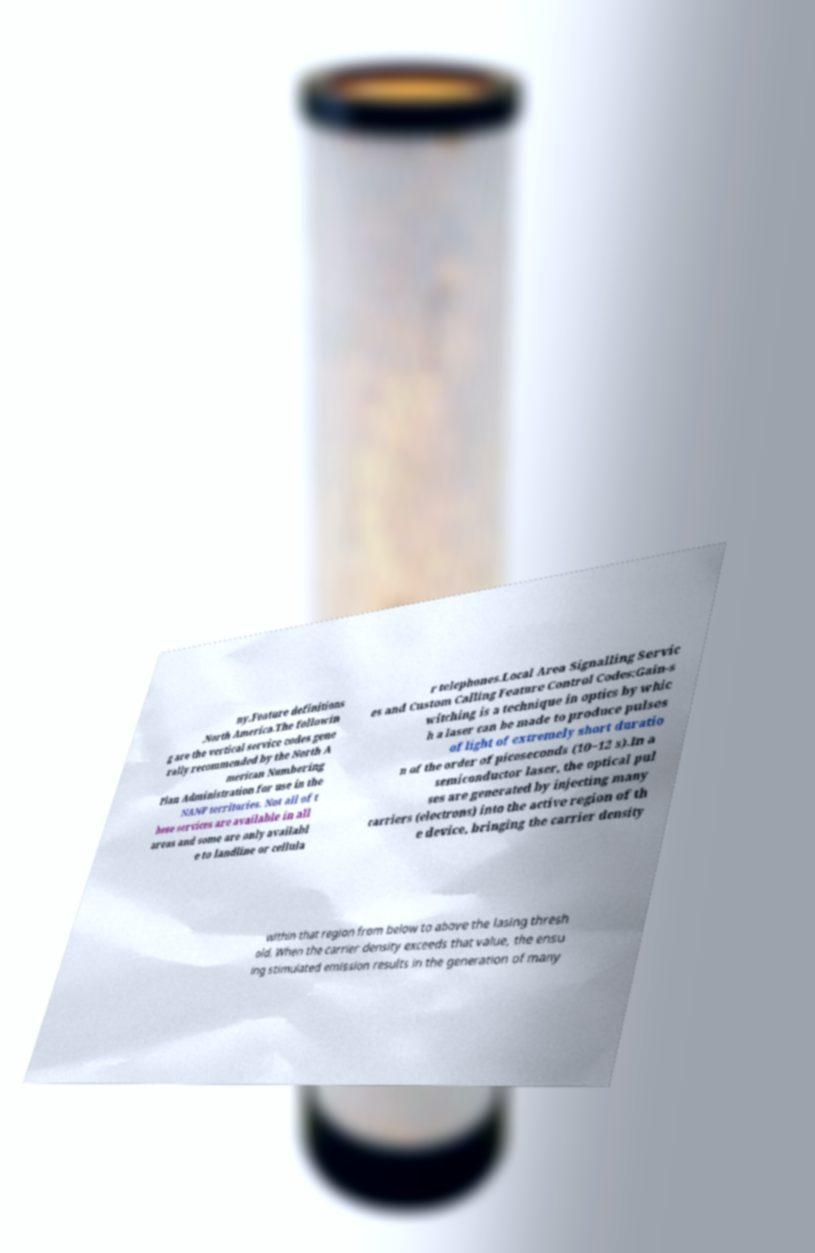Please read and relay the text visible in this image. What does it say? ny.Feature definitions .North America.The followin g are the vertical service codes gene rally recommended by the North A merican Numbering Plan Administration for use in the NANP territories. Not all of t hese services are available in all areas and some are only availabl e to landline or cellula r telephones.Local Area Signalling Servic es and Custom Calling Feature Control Codes:Gain-s witching is a technique in optics by whic h a laser can be made to produce pulses of light of extremely short duratio n of the order of picoseconds (10−12 s).In a semiconductor laser, the optical pul ses are generated by injecting many carriers (electrons) into the active region of th e device, bringing the carrier density within that region from below to above the lasing thresh old. When the carrier density exceeds that value, the ensu ing stimulated emission results in the generation of many 